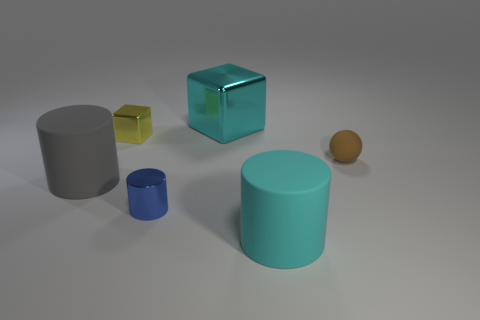The cyan thing that is the same shape as the blue metal thing is what size?
Provide a succinct answer. Large. The large thing that is in front of the sphere and behind the cyan matte thing is made of what material?
Provide a succinct answer. Rubber. What is the color of the other big metal thing that is the same shape as the yellow metal object?
Provide a succinct answer. Cyan. What is the size of the blue metal cylinder?
Provide a short and direct response. Small. The small shiny object that is behind the large cylinder that is on the left side of the small cube is what color?
Offer a very short reply. Yellow. What number of things are both to the left of the tiny blue cylinder and in front of the tiny brown ball?
Your response must be concise. 1. Is the number of brown rubber spheres greater than the number of small objects?
Your answer should be compact. No. What is the cyan block made of?
Provide a short and direct response. Metal. There is a rubber sphere that is to the right of the big metallic thing; what number of large cyan blocks are in front of it?
Provide a succinct answer. 0. There is a tiny cube; is its color the same as the big thing behind the brown ball?
Offer a very short reply. No. 